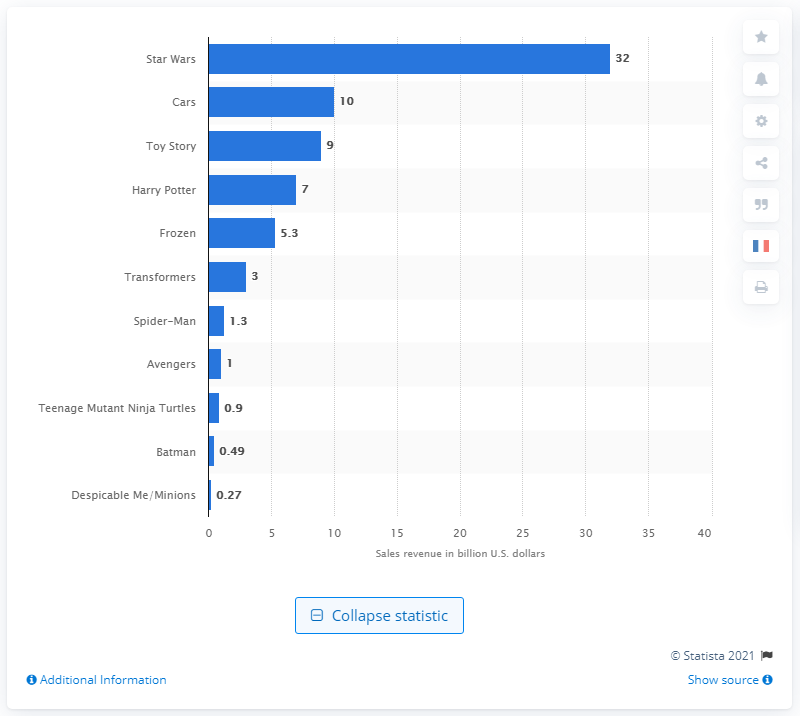Highlight a few significant elements in this photo. As of January 2016, the Star Wars franchise generated approximately $32 billion in merchandise sales revenue. The second most popular movie of 2016 was "Cars 